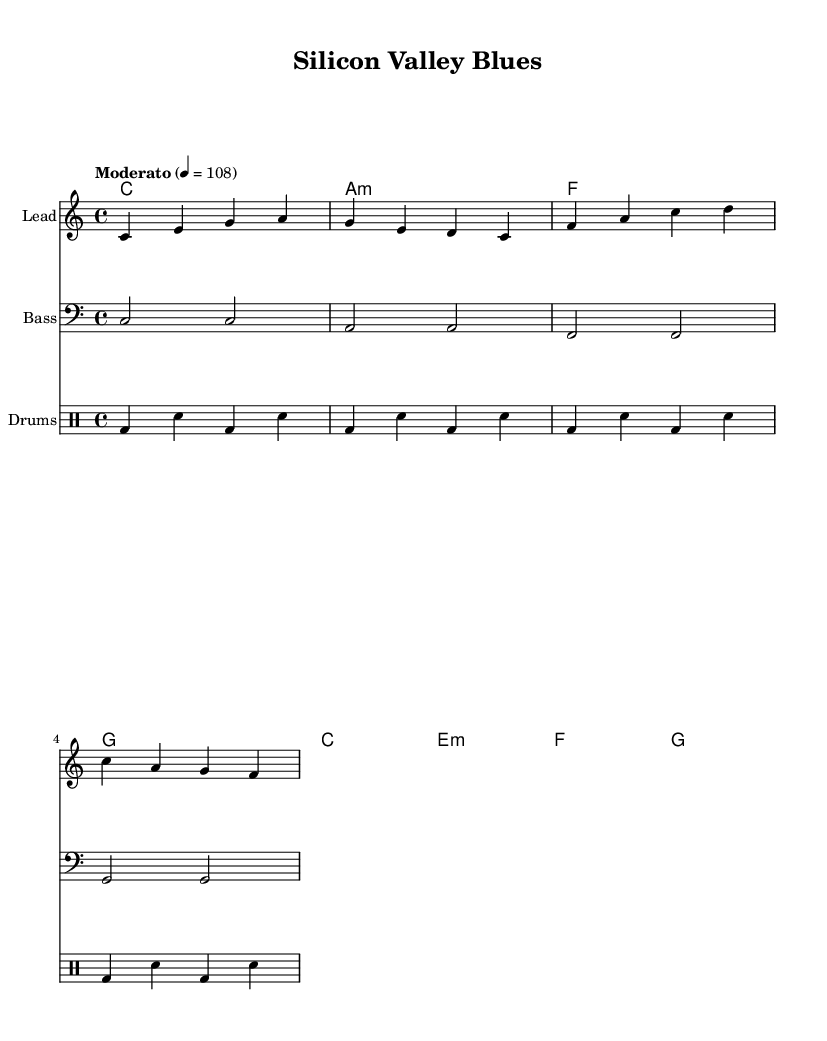What is the key signature of this music? The key signature is indicated by the absence of any sharps or flats at the beginning of the staff. This corresponds to the key of C major.
Answer: C major What is the time signature of this piece? The time signature is located at the beginning of the staff, showing a 4 over 4, which means four beats per measure and a quarter note receives one beat.
Answer: 4/4 What is the tempo marking for this composition? The tempo is given as "Moderato," which is a common Italian term indicating a moderate pace, and the accompanying metronome marking indicates a speed of 108 beats per minute.
Answer: Moderato, 108 What is the main theme explored in the lyrics? The lyrics focus on coding dreams, the startup culture, and the ethical dilemmas faced in the tech industry, reflecting on the juxtaposition between progress and regress.
Answer: Ethical dilemmas How many measures are there in the melody section? By counting the individual measures in the melody part, which are divided by vertical lines (bar lines), we can determine that there are a total of four measures presented in the melody.
Answer: 4 What chords are used in the chorus? The chorus section outlines specific chords that can be identified above the lyrics, including C major, E minor, F major, and G major, which are commonly used in popular music.
Answer: C, E minor, F, G How does the drum part contribute to the overall feeling of the song? The drum part uses a simple repeating pattern that includes bass and snare hits, creating a driving rhythm that complements the moderate tempo and maintains energy throughout.
Answer: Driving rhythm 